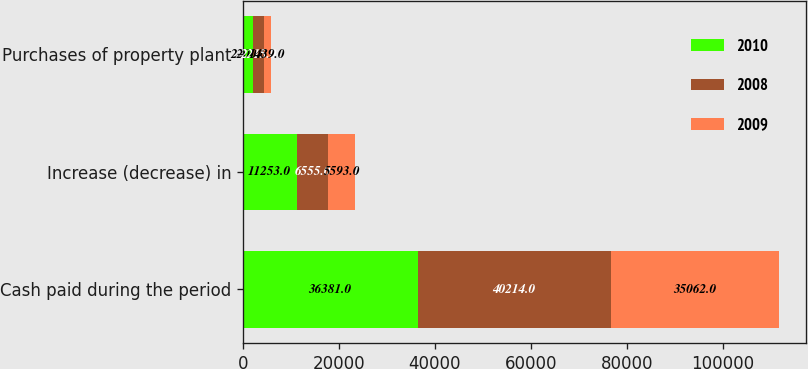Convert chart to OTSL. <chart><loc_0><loc_0><loc_500><loc_500><stacked_bar_chart><ecel><fcel>Cash paid during the period<fcel>Increase (decrease) in<fcel>Purchases of property plant<nl><fcel>2010<fcel>36381<fcel>11253<fcel>2200<nl><fcel>2008<fcel>40214<fcel>6555<fcel>2215<nl><fcel>2009<fcel>35062<fcel>5593<fcel>1439<nl></chart> 